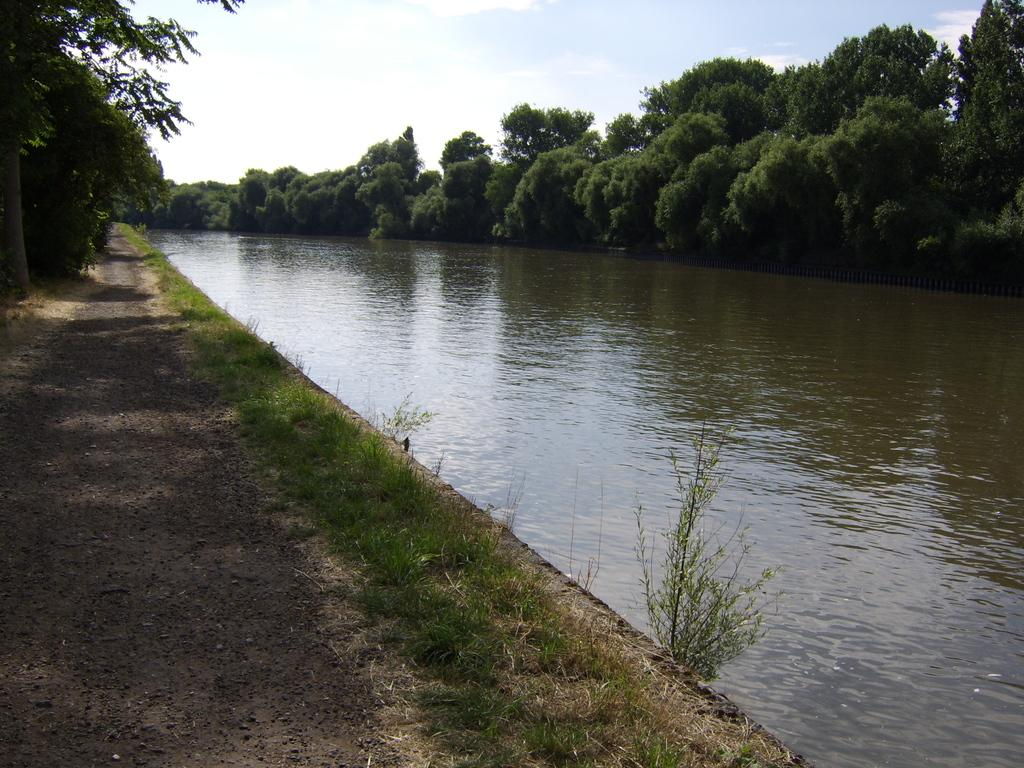What is the primary element visible in the image? There is water in the image. What type of vegetation can be seen near the water? There is grass on both sides of the water. What other natural elements are present in the image? There are many trees in the image. What can be seen in the background of the image? There are clouds and the sky visible in the background. How many frogs are sitting on the sand in the image? There is no sand or frogs present in the image. 